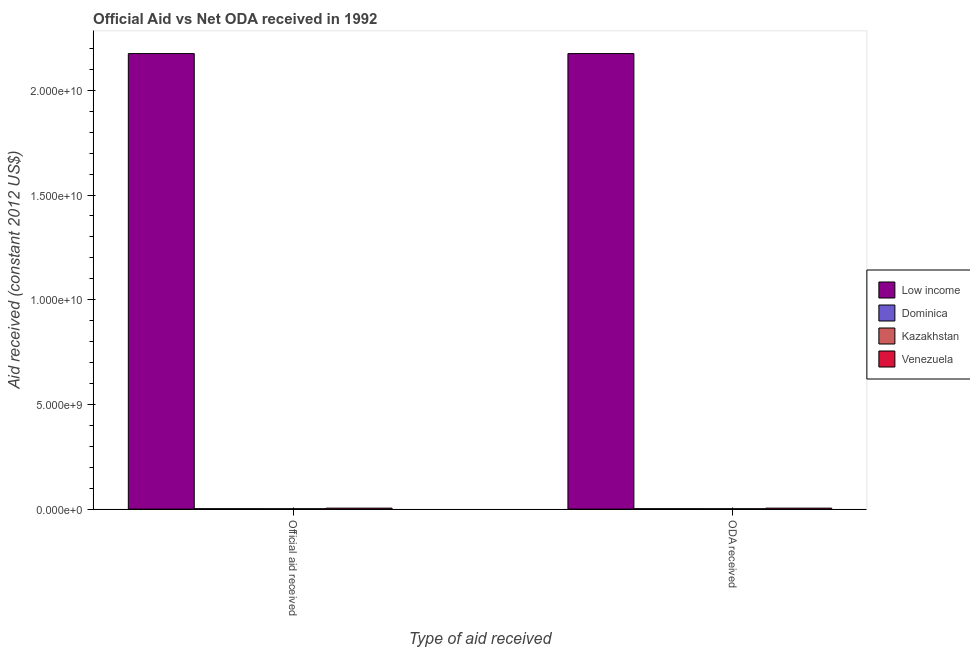How many different coloured bars are there?
Ensure brevity in your answer.  4. How many groups of bars are there?
Provide a short and direct response. 2. Are the number of bars per tick equal to the number of legend labels?
Give a very brief answer. Yes. Are the number of bars on each tick of the X-axis equal?
Your answer should be compact. Yes. How many bars are there on the 1st tick from the left?
Offer a very short reply. 4. What is the label of the 1st group of bars from the left?
Provide a succinct answer. Official aid received. What is the official aid received in Venezuela?
Your response must be concise. 4.60e+07. Across all countries, what is the maximum oda received?
Give a very brief answer. 2.18e+1. Across all countries, what is the minimum official aid received?
Ensure brevity in your answer.  1.74e+07. In which country was the oda received maximum?
Provide a succinct answer. Low income. In which country was the official aid received minimum?
Provide a succinct answer. Kazakhstan. What is the total oda received in the graph?
Offer a very short reply. 2.18e+1. What is the difference between the official aid received in Venezuela and that in Dominica?
Give a very brief answer. 2.78e+07. What is the difference between the official aid received in Dominica and the oda received in Kazakhstan?
Your answer should be very brief. 8.30e+05. What is the average oda received per country?
Give a very brief answer. 5.46e+09. In how many countries, is the oda received greater than 11000000000 US$?
Your response must be concise. 1. What is the ratio of the oda received in Venezuela to that in Kazakhstan?
Ensure brevity in your answer.  2.65. What does the 4th bar from the left in Official aid received represents?
Your answer should be compact. Venezuela. What does the 4th bar from the right in Official aid received represents?
Your answer should be very brief. Low income. Are the values on the major ticks of Y-axis written in scientific E-notation?
Ensure brevity in your answer.  Yes. How many legend labels are there?
Make the answer very short. 4. What is the title of the graph?
Make the answer very short. Official Aid vs Net ODA received in 1992 . Does "Madagascar" appear as one of the legend labels in the graph?
Keep it short and to the point. No. What is the label or title of the X-axis?
Your answer should be compact. Type of aid received. What is the label or title of the Y-axis?
Your answer should be very brief. Aid received (constant 2012 US$). What is the Aid received (constant 2012 US$) of Low income in Official aid received?
Your answer should be compact. 2.18e+1. What is the Aid received (constant 2012 US$) in Dominica in Official aid received?
Give a very brief answer. 1.82e+07. What is the Aid received (constant 2012 US$) of Kazakhstan in Official aid received?
Make the answer very short. 1.74e+07. What is the Aid received (constant 2012 US$) in Venezuela in Official aid received?
Ensure brevity in your answer.  4.60e+07. What is the Aid received (constant 2012 US$) in Low income in ODA received?
Offer a terse response. 2.18e+1. What is the Aid received (constant 2012 US$) of Dominica in ODA received?
Offer a very short reply. 1.82e+07. What is the Aid received (constant 2012 US$) of Kazakhstan in ODA received?
Your answer should be compact. 1.74e+07. What is the Aid received (constant 2012 US$) in Venezuela in ODA received?
Your answer should be very brief. 4.60e+07. Across all Type of aid received, what is the maximum Aid received (constant 2012 US$) of Low income?
Give a very brief answer. 2.18e+1. Across all Type of aid received, what is the maximum Aid received (constant 2012 US$) of Dominica?
Ensure brevity in your answer.  1.82e+07. Across all Type of aid received, what is the maximum Aid received (constant 2012 US$) in Kazakhstan?
Make the answer very short. 1.74e+07. Across all Type of aid received, what is the maximum Aid received (constant 2012 US$) in Venezuela?
Your answer should be compact. 4.60e+07. Across all Type of aid received, what is the minimum Aid received (constant 2012 US$) in Low income?
Give a very brief answer. 2.18e+1. Across all Type of aid received, what is the minimum Aid received (constant 2012 US$) of Dominica?
Your answer should be compact. 1.82e+07. Across all Type of aid received, what is the minimum Aid received (constant 2012 US$) of Kazakhstan?
Your answer should be very brief. 1.74e+07. Across all Type of aid received, what is the minimum Aid received (constant 2012 US$) in Venezuela?
Ensure brevity in your answer.  4.60e+07. What is the total Aid received (constant 2012 US$) in Low income in the graph?
Give a very brief answer. 4.35e+1. What is the total Aid received (constant 2012 US$) of Dominica in the graph?
Give a very brief answer. 3.64e+07. What is the total Aid received (constant 2012 US$) in Kazakhstan in the graph?
Keep it short and to the point. 3.48e+07. What is the total Aid received (constant 2012 US$) of Venezuela in the graph?
Offer a terse response. 9.20e+07. What is the difference between the Aid received (constant 2012 US$) in Low income in Official aid received and that in ODA received?
Your answer should be compact. 0. What is the difference between the Aid received (constant 2012 US$) in Kazakhstan in Official aid received and that in ODA received?
Provide a succinct answer. 0. What is the difference between the Aid received (constant 2012 US$) in Low income in Official aid received and the Aid received (constant 2012 US$) in Dominica in ODA received?
Offer a terse response. 2.17e+1. What is the difference between the Aid received (constant 2012 US$) of Low income in Official aid received and the Aid received (constant 2012 US$) of Kazakhstan in ODA received?
Your response must be concise. 2.17e+1. What is the difference between the Aid received (constant 2012 US$) in Low income in Official aid received and the Aid received (constant 2012 US$) in Venezuela in ODA received?
Make the answer very short. 2.17e+1. What is the difference between the Aid received (constant 2012 US$) in Dominica in Official aid received and the Aid received (constant 2012 US$) in Kazakhstan in ODA received?
Your response must be concise. 8.30e+05. What is the difference between the Aid received (constant 2012 US$) of Dominica in Official aid received and the Aid received (constant 2012 US$) of Venezuela in ODA received?
Your answer should be very brief. -2.78e+07. What is the difference between the Aid received (constant 2012 US$) in Kazakhstan in Official aid received and the Aid received (constant 2012 US$) in Venezuela in ODA received?
Ensure brevity in your answer.  -2.86e+07. What is the average Aid received (constant 2012 US$) in Low income per Type of aid received?
Keep it short and to the point. 2.18e+1. What is the average Aid received (constant 2012 US$) of Dominica per Type of aid received?
Ensure brevity in your answer.  1.82e+07. What is the average Aid received (constant 2012 US$) in Kazakhstan per Type of aid received?
Provide a succinct answer. 1.74e+07. What is the average Aid received (constant 2012 US$) in Venezuela per Type of aid received?
Provide a short and direct response. 4.60e+07. What is the difference between the Aid received (constant 2012 US$) of Low income and Aid received (constant 2012 US$) of Dominica in Official aid received?
Give a very brief answer. 2.17e+1. What is the difference between the Aid received (constant 2012 US$) of Low income and Aid received (constant 2012 US$) of Kazakhstan in Official aid received?
Ensure brevity in your answer.  2.17e+1. What is the difference between the Aid received (constant 2012 US$) in Low income and Aid received (constant 2012 US$) in Venezuela in Official aid received?
Provide a short and direct response. 2.17e+1. What is the difference between the Aid received (constant 2012 US$) of Dominica and Aid received (constant 2012 US$) of Kazakhstan in Official aid received?
Give a very brief answer. 8.30e+05. What is the difference between the Aid received (constant 2012 US$) of Dominica and Aid received (constant 2012 US$) of Venezuela in Official aid received?
Your answer should be very brief. -2.78e+07. What is the difference between the Aid received (constant 2012 US$) in Kazakhstan and Aid received (constant 2012 US$) in Venezuela in Official aid received?
Make the answer very short. -2.86e+07. What is the difference between the Aid received (constant 2012 US$) in Low income and Aid received (constant 2012 US$) in Dominica in ODA received?
Ensure brevity in your answer.  2.17e+1. What is the difference between the Aid received (constant 2012 US$) in Low income and Aid received (constant 2012 US$) in Kazakhstan in ODA received?
Offer a terse response. 2.17e+1. What is the difference between the Aid received (constant 2012 US$) of Low income and Aid received (constant 2012 US$) of Venezuela in ODA received?
Give a very brief answer. 2.17e+1. What is the difference between the Aid received (constant 2012 US$) in Dominica and Aid received (constant 2012 US$) in Kazakhstan in ODA received?
Offer a terse response. 8.30e+05. What is the difference between the Aid received (constant 2012 US$) of Dominica and Aid received (constant 2012 US$) of Venezuela in ODA received?
Your answer should be very brief. -2.78e+07. What is the difference between the Aid received (constant 2012 US$) in Kazakhstan and Aid received (constant 2012 US$) in Venezuela in ODA received?
Your response must be concise. -2.86e+07. What is the ratio of the Aid received (constant 2012 US$) of Venezuela in Official aid received to that in ODA received?
Your answer should be very brief. 1. What is the difference between the highest and the second highest Aid received (constant 2012 US$) of Dominica?
Your answer should be compact. 0. What is the difference between the highest and the lowest Aid received (constant 2012 US$) of Low income?
Provide a short and direct response. 0. What is the difference between the highest and the lowest Aid received (constant 2012 US$) of Dominica?
Provide a succinct answer. 0. What is the difference between the highest and the lowest Aid received (constant 2012 US$) of Kazakhstan?
Make the answer very short. 0. 